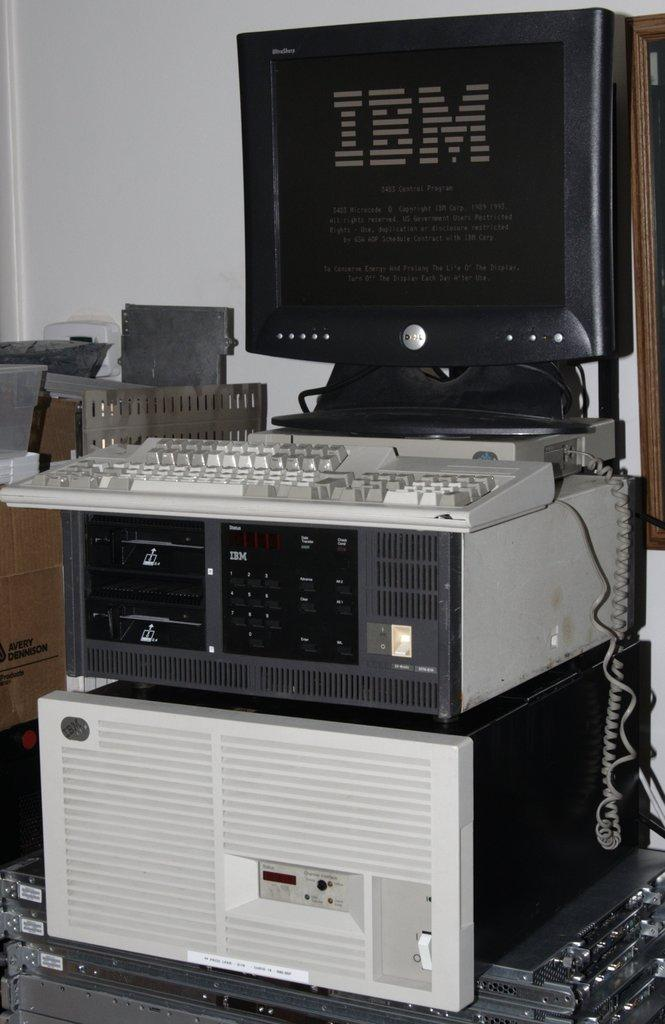<image>
Render a clear and concise summary of the photo. An IBM computer sitting in a rack with keyboard 